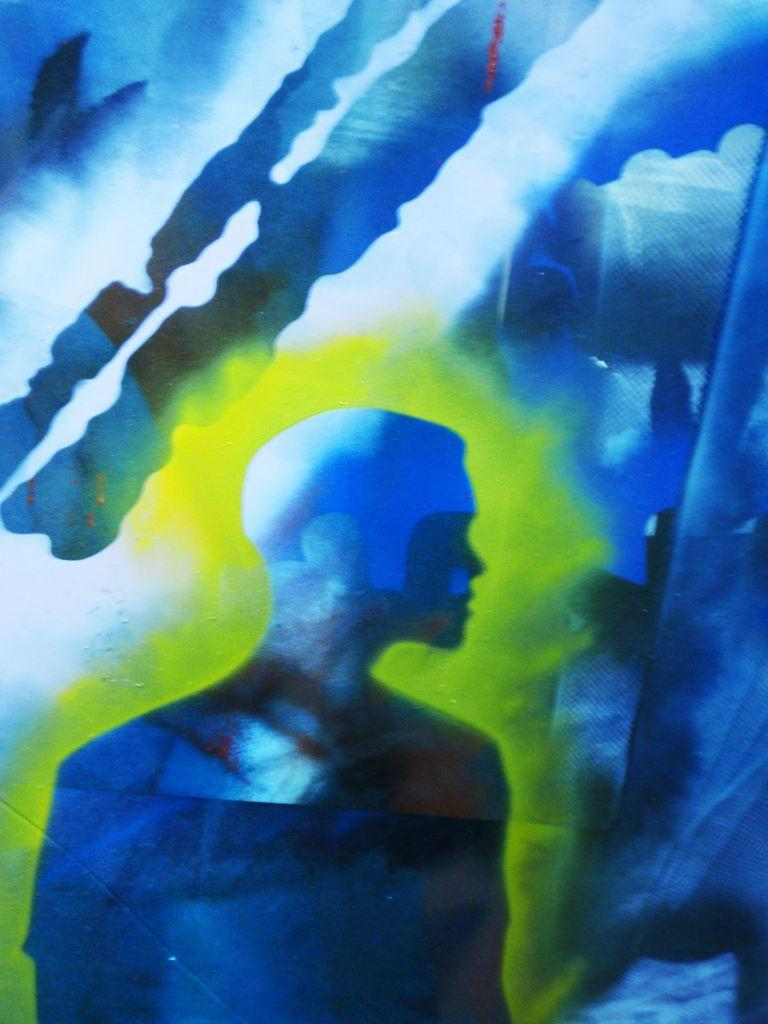What is the main subject of the image? There is a shape resembling a person in the image. What color is the person-shaped object? The shape is in blue color. What color is the area surrounding the person-shaped object? The area around the person-shaped object is in cream color. How would you describe the background of the image? The background of the image is in blue and white color. What type of pancake is being served in the image? There is no pancake present in the image; it features a person-shaped object in blue color. What news event is depicted in the image? There is no news event depicted in the image; it features a person-shaped object in blue color. 